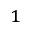<formula> <loc_0><loc_0><loc_500><loc_500>^ { 1 }</formula> 